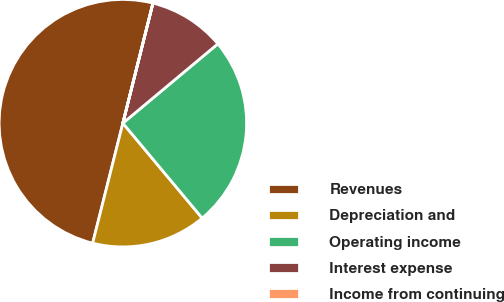Convert chart to OTSL. <chart><loc_0><loc_0><loc_500><loc_500><pie_chart><fcel>Revenues<fcel>Depreciation and<fcel>Operating income<fcel>Interest expense<fcel>Income from continuing<nl><fcel>49.98%<fcel>15.0%<fcel>25.0%<fcel>10.01%<fcel>0.01%<nl></chart> 